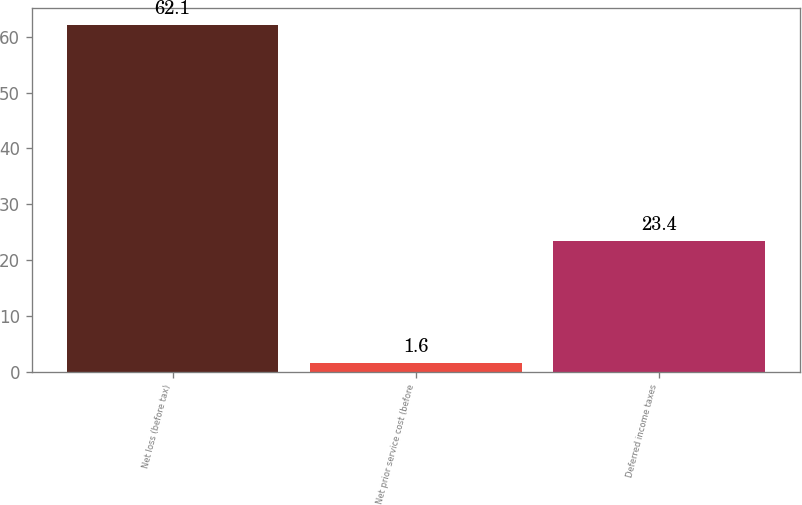Convert chart. <chart><loc_0><loc_0><loc_500><loc_500><bar_chart><fcel>Net loss (before tax)<fcel>Net prior service cost (before<fcel>Deferred income taxes<nl><fcel>62.1<fcel>1.6<fcel>23.4<nl></chart> 